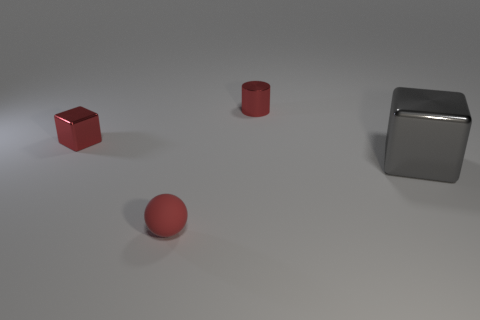Add 3 big blocks. How many objects exist? 7 Subtract all spheres. How many objects are left? 3 Add 1 blue spheres. How many blue spheres exist? 1 Subtract 0 brown cubes. How many objects are left? 4 Subtract all big brown rubber balls. Subtract all tiny red shiny objects. How many objects are left? 2 Add 4 gray metallic cubes. How many gray metallic cubes are left? 5 